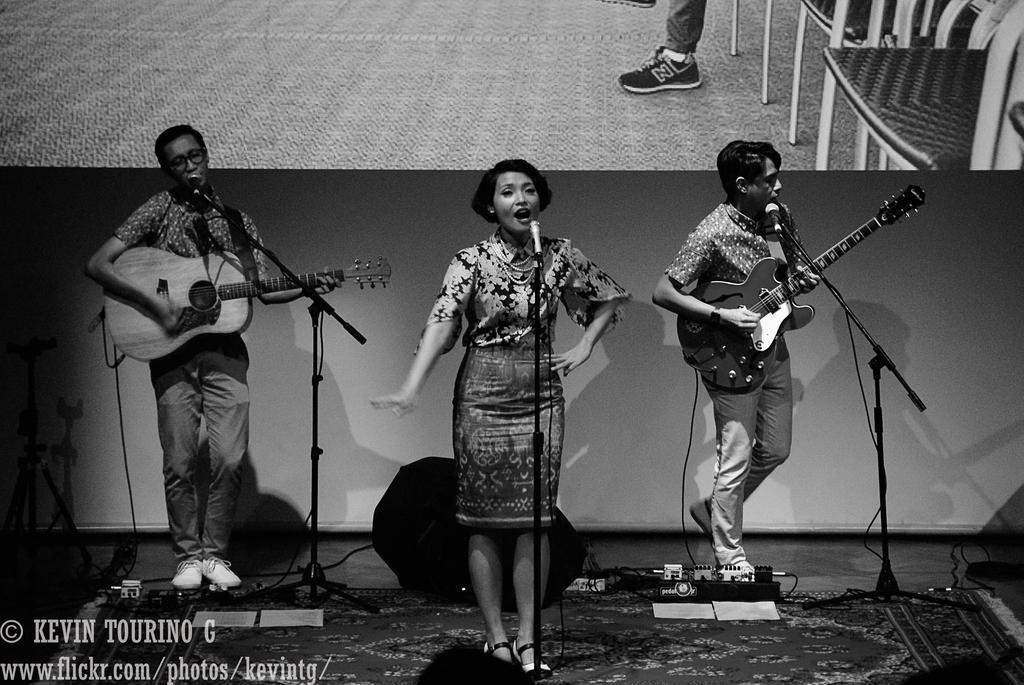In one or two sentences, can you explain what this image depicts? In this image I can see there are three people among them two are man who are playing guitar and singing song in front of the microphone. And a woman who is also singing in front of the microphone. 